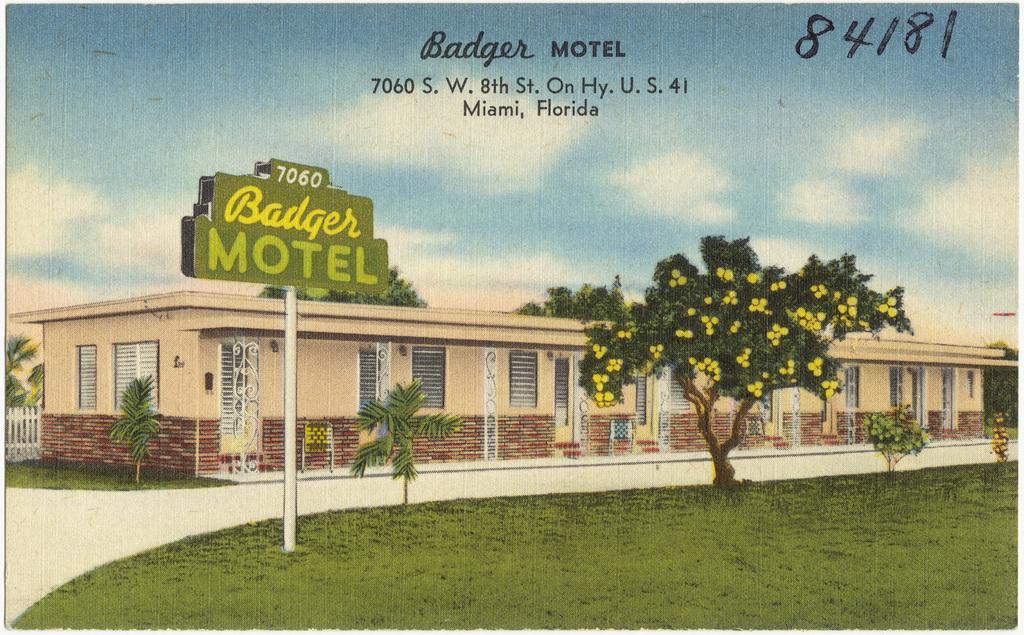Could you give a brief overview of what you see in this image? This image consists of a painting. At the bottom I can see the grass and there is a road. On the both sides of the road there are some trees. In the background, I can see a building. On the left side, I can see a pole to which a board is attached. At the top I can see the sky. At the top of this image I can see some text. 